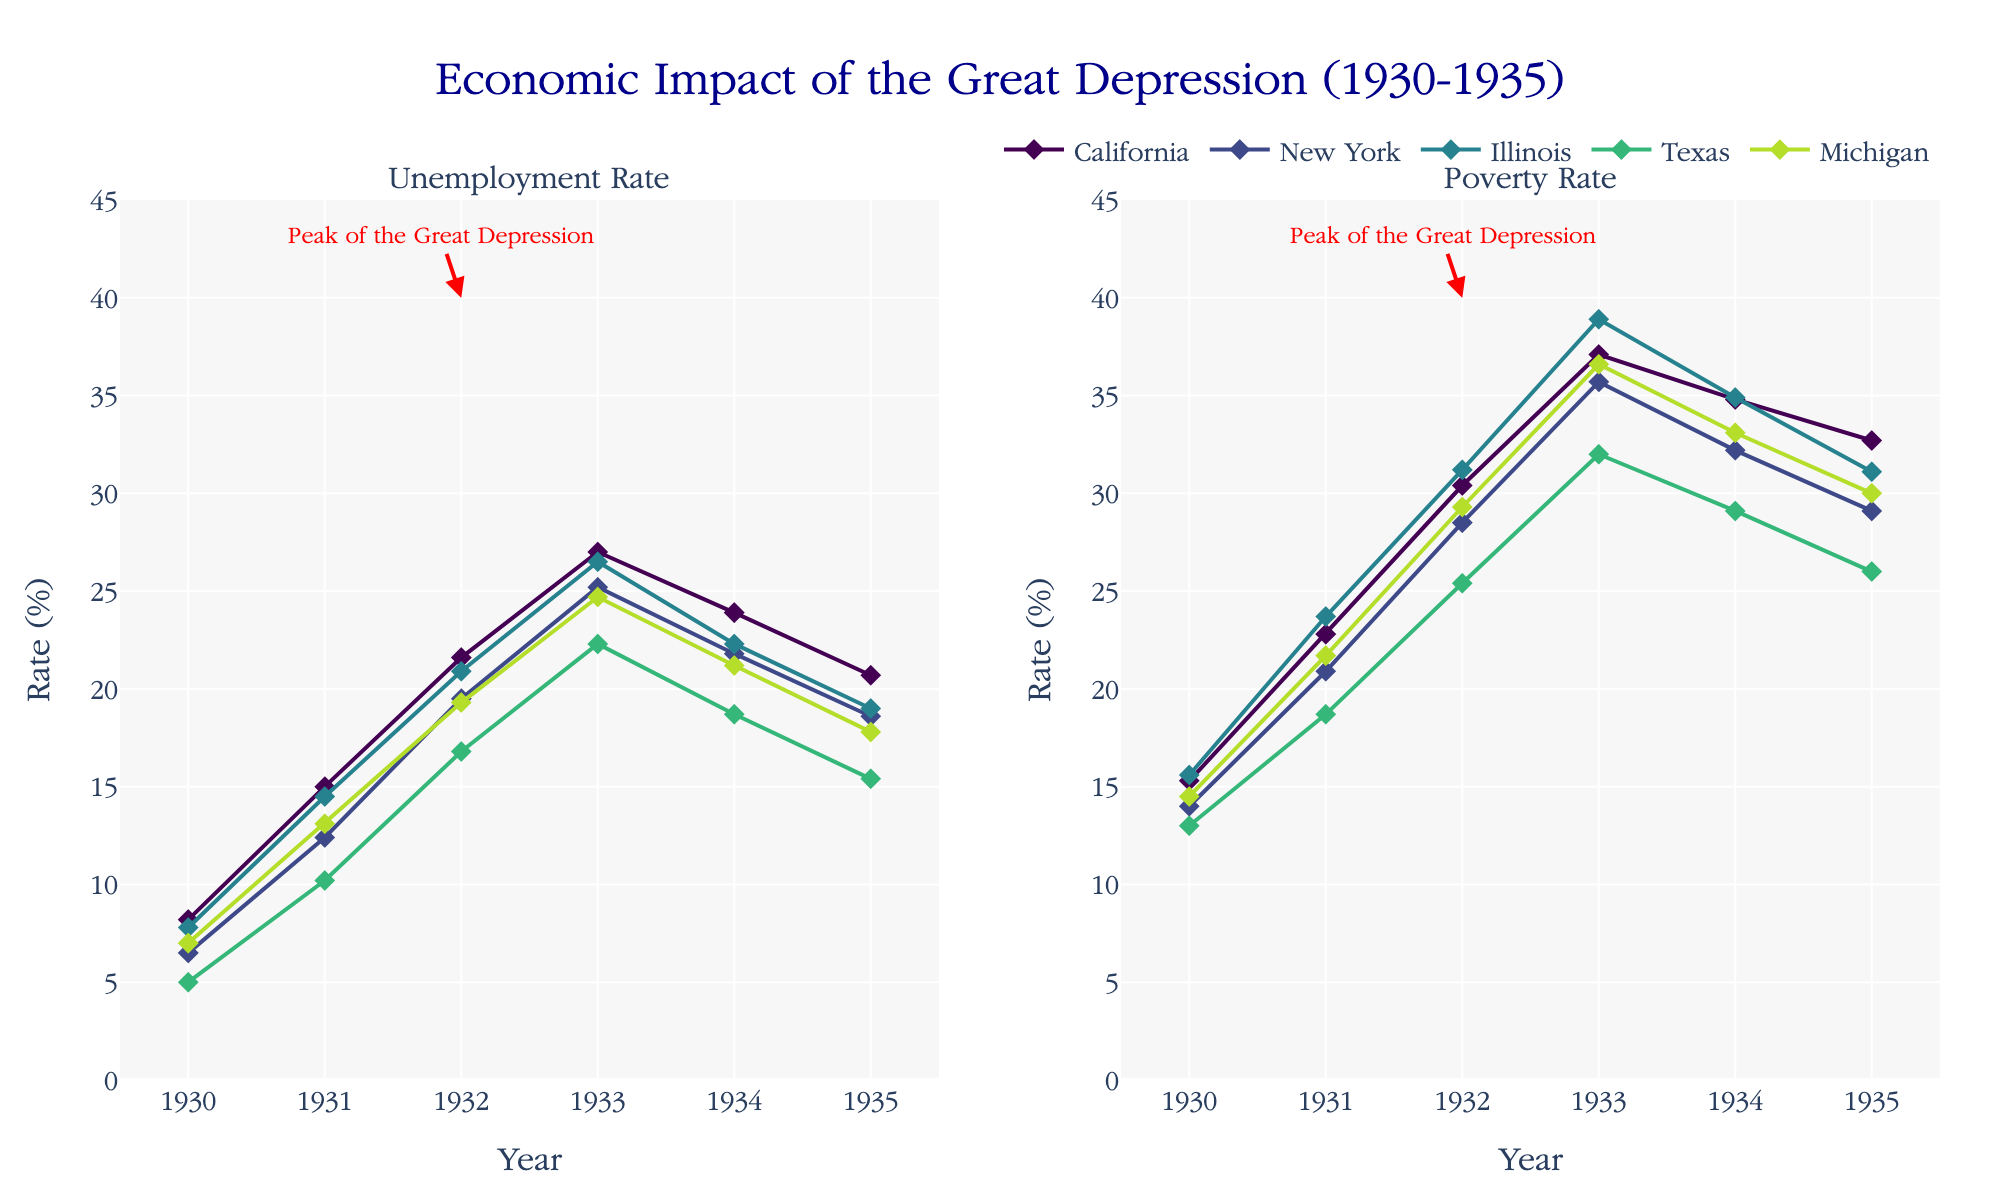What is the title of the figure? The title is displayed at the top center of the figure. It reads, "Economic Impact of the Great Depression (1930-1935)".
Answer: Economic Impact of the Great Depression (1930-1935) What is the range of the x-axis? The x-axis represents the years and it ranges from 1929.5 to 1935.5. This is evident from the labels on the x-axis.
Answer: 1929.5 to 1935.5 Which year has the highest unemployment rate according to the figure? The annotation marks the peak of the Great Depression in 1932 on both subplots, indicating the highest values for the unemployment rate. Observing the graph of each state, the highest unemployment rates are indeed around 1932.
Answer: 1932 Which state had the lowest poverty rate in 1933? By comparing the data points for each state in 1933 on the right subplot, Texas is observed to have the lowest poverty rate.
Answer: Texas By how many percentage points did California’s unemployment rate change from 1933 to 1934? California's unemployment rate in 1933 was 27.0%, and in 1934 it was 23.9%. The change is calculated by taking the difference: 27.0% - 23.9% = 3.1%.
Answer: 3.1% Compare the poverty rate of New York and Illinois in 1932. Which state had a higher rate and by how much? In 1932, New York’s poverty rate was 28.5%, and Illinois’s poverty rate was 31.2%. Illinois had a higher poverty rate by 31.2% - 28.5% = 2.7%.
Answer: Illinois by 2.7% During which year did Texas's unemployment rate increase the most, and by how many percentage points? From the plot, Texas’s unemployment rate increased notably between 1930 and 1931 (from 5.0% to 10.2%), which is an increase of 10.2% - 5.0% = 5.2 percentage points.
Answer: 1931 by 5.2 percentage points What is the overall trend of the poverty rate from 1930 to 1935 for New York? Observing the right subplot, New York’s poverty rate increases from 1930 to 1933 and then declines from 1933 to 1935. This trend indicates an initial rise followed by a decline.
Answer: Rises then declines How do the unemployment rates of California and Michigan in 1935 compare to their rates in 1930? In 1930, California had an unemployment rate of 8.2% and Michigan had 7.0%. In 1935, California’s rate was 20.7% and Michigan’s rate was 17.8%. Comparing the values, both states experienced a significant increase, with California rising by 12.5 percentage points and Michigan by 10.8 percentage points.
Answer: Both increased; California by 12.5%, Michigan by 10.8% Which state shows a similar trajectory in the unemployment rate as California from 1930 to 1935? Carefully interpreting the trajectory of lines, Illinois shows a similar trend as California, where the unemployment rate rises sharply till around 1933, then begins to decline.
Answer: Illinois 